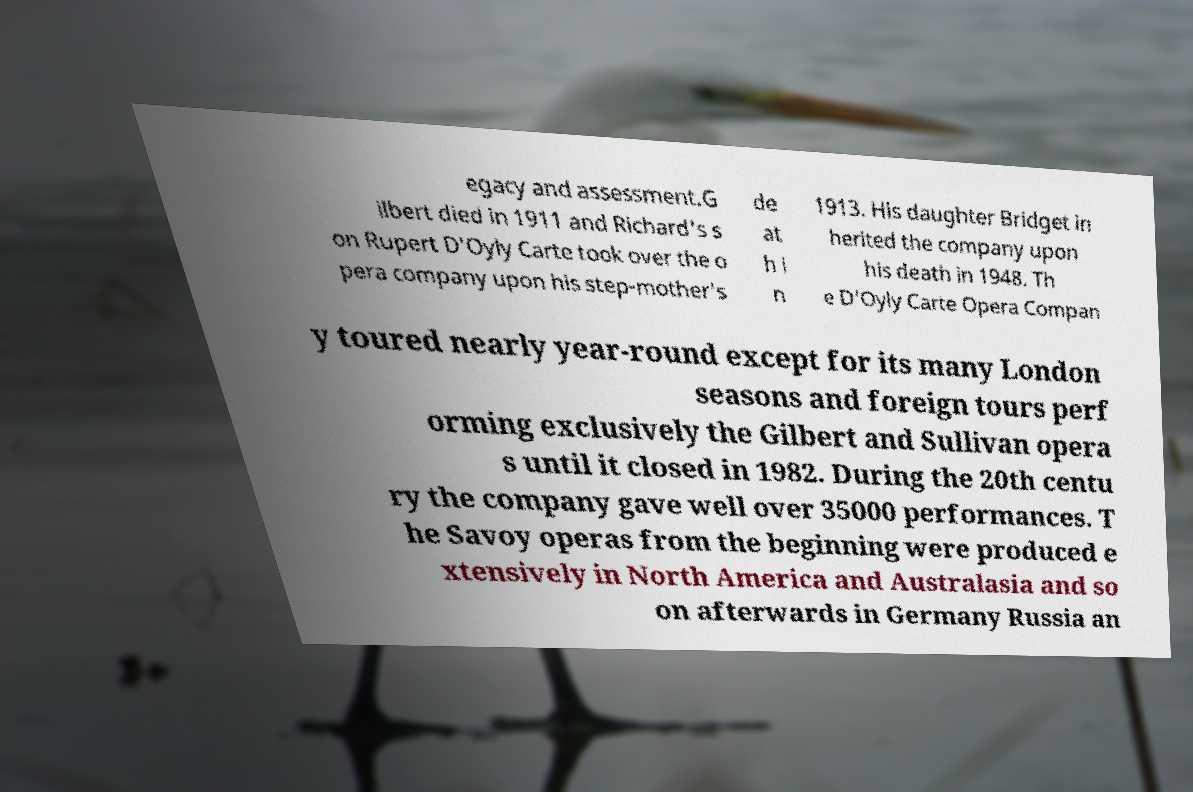There's text embedded in this image that I need extracted. Can you transcribe it verbatim? egacy and assessment.G ilbert died in 1911 and Richard's s on Rupert D'Oyly Carte took over the o pera company upon his step-mother's de at h i n 1913. His daughter Bridget in herited the company upon his death in 1948. Th e D'Oyly Carte Opera Compan y toured nearly year-round except for its many London seasons and foreign tours perf orming exclusively the Gilbert and Sullivan opera s until it closed in 1982. During the 20th centu ry the company gave well over 35000 performances. T he Savoy operas from the beginning were produced e xtensively in North America and Australasia and so on afterwards in Germany Russia an 